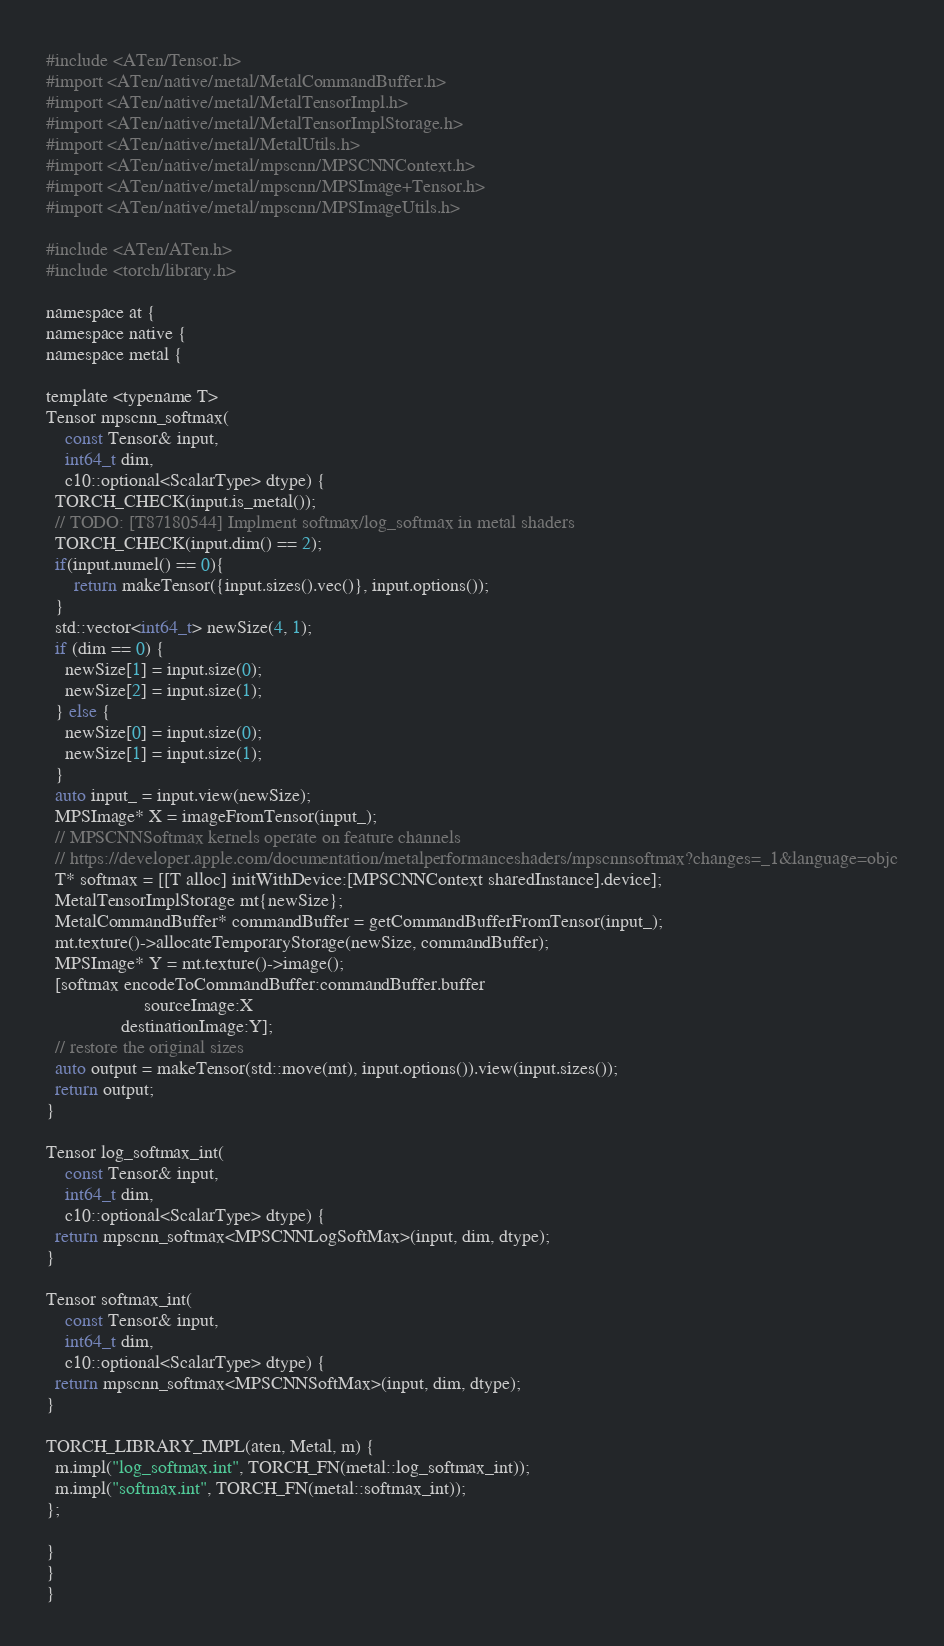<code> <loc_0><loc_0><loc_500><loc_500><_ObjectiveC_>#include <ATen/Tensor.h>
#import <ATen/native/metal/MetalCommandBuffer.h>
#import <ATen/native/metal/MetalTensorImpl.h>
#import <ATen/native/metal/MetalTensorImplStorage.h>
#import <ATen/native/metal/MetalUtils.h>
#import <ATen/native/metal/mpscnn/MPSCNNContext.h>
#import <ATen/native/metal/mpscnn/MPSImage+Tensor.h>
#import <ATen/native/metal/mpscnn/MPSImageUtils.h>

#include <ATen/ATen.h>
#include <torch/library.h>

namespace at {
namespace native {
namespace metal {

template <typename T>
Tensor mpscnn_softmax(
    const Tensor& input,
    int64_t dim,
    c10::optional<ScalarType> dtype) {
  TORCH_CHECK(input.is_metal());
  // TODO: [T87180544] Implment softmax/log_softmax in metal shaders
  TORCH_CHECK(input.dim() == 2);
  if(input.numel() == 0){
      return makeTensor({input.sizes().vec()}, input.options());
  }
  std::vector<int64_t> newSize(4, 1);
  if (dim == 0) {
    newSize[1] = input.size(0);
    newSize[2] = input.size(1);
  } else {
    newSize[0] = input.size(0);
    newSize[1] = input.size(1);
  }
  auto input_ = input.view(newSize);
  MPSImage* X = imageFromTensor(input_);
  // MPSCNNSoftmax kernels operate on feature channels
  // https://developer.apple.com/documentation/metalperformanceshaders/mpscnnsoftmax?changes=_1&language=objc
  T* softmax = [[T alloc] initWithDevice:[MPSCNNContext sharedInstance].device];
  MetalTensorImplStorage mt{newSize};
  MetalCommandBuffer* commandBuffer = getCommandBufferFromTensor(input_);
  mt.texture()->allocateTemporaryStorage(newSize, commandBuffer);
  MPSImage* Y = mt.texture()->image();
  [softmax encodeToCommandBuffer:commandBuffer.buffer
                     sourceImage:X
                destinationImage:Y];
  // restore the original sizes
  auto output = makeTensor(std::move(mt), input.options()).view(input.sizes());
  return output;
}

Tensor log_softmax_int(
    const Tensor& input,
    int64_t dim,
    c10::optional<ScalarType> dtype) {
  return mpscnn_softmax<MPSCNNLogSoftMax>(input, dim, dtype);
}

Tensor softmax_int(
    const Tensor& input,
    int64_t dim,
    c10::optional<ScalarType> dtype) {
  return mpscnn_softmax<MPSCNNSoftMax>(input, dim, dtype);
}

TORCH_LIBRARY_IMPL(aten, Metal, m) {
  m.impl("log_softmax.int", TORCH_FN(metal::log_softmax_int));
  m.impl("softmax.int", TORCH_FN(metal::softmax_int));
};

}
}
}
</code> 